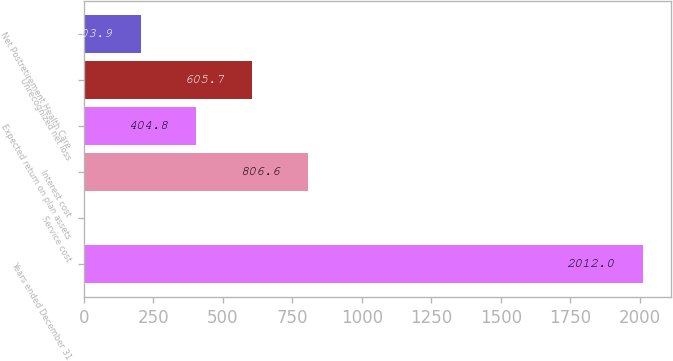Convert chart. <chart><loc_0><loc_0><loc_500><loc_500><bar_chart><fcel>Years ended December 31<fcel>Service cost<fcel>Interest cost<fcel>Expected return on plan assets<fcel>Unrecognized net loss<fcel>Net Postretirement Health Care<nl><fcel>2012<fcel>3<fcel>806.6<fcel>404.8<fcel>605.7<fcel>203.9<nl></chart> 